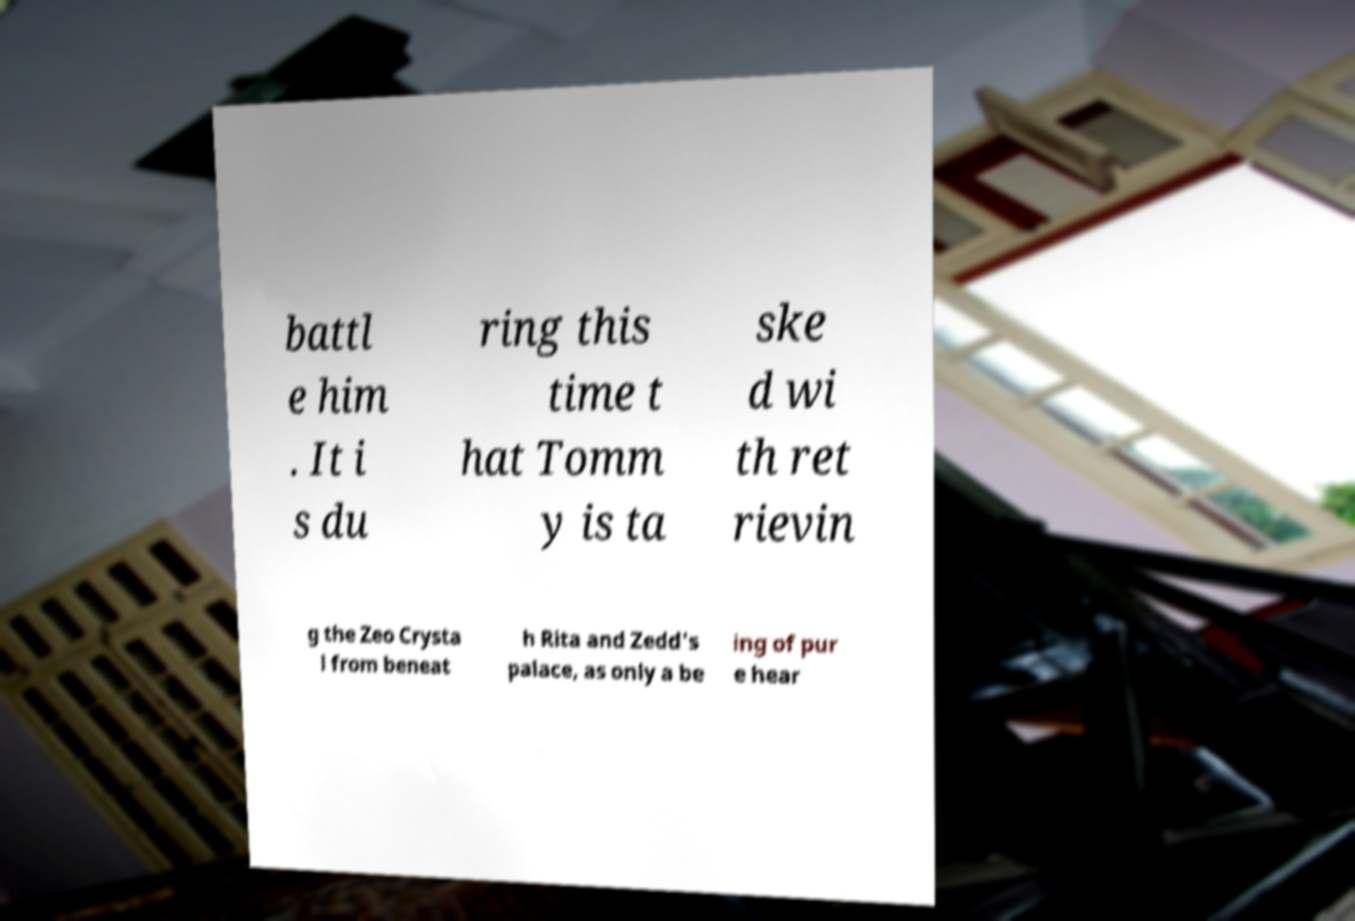For documentation purposes, I need the text within this image transcribed. Could you provide that? battl e him . It i s du ring this time t hat Tomm y is ta ske d wi th ret rievin g the Zeo Crysta l from beneat h Rita and Zedd's palace, as only a be ing of pur e hear 